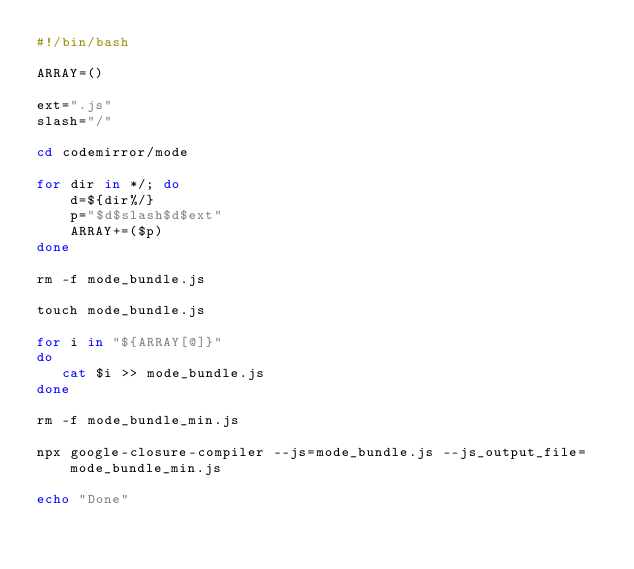<code> <loc_0><loc_0><loc_500><loc_500><_Bash_>#!/bin/bash

ARRAY=()

ext=".js"
slash="/"

cd codemirror/mode

for dir in */; do
	d=${dir%/}
	p="$d$slash$d$ext"
	ARRAY+=($p)
done

rm -f mode_bundle.js

touch mode_bundle.js

for i in "${ARRAY[@]}"
do
   cat $i >> mode_bundle.js
done

rm -f mode_bundle_min.js

npx google-closure-compiler --js=mode_bundle.js --js_output_file=mode_bundle_min.js

echo "Done"
</code> 